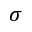<formula> <loc_0><loc_0><loc_500><loc_500>\sigma</formula> 